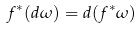Convert formula to latex. <formula><loc_0><loc_0><loc_500><loc_500>f ^ { * } ( d \omega ) = d ( f ^ { * } \omega )</formula> 